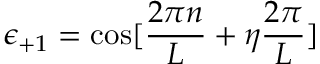<formula> <loc_0><loc_0><loc_500><loc_500>\epsilon _ { + 1 } = \cos [ \frac { 2 \pi n } { L } + \eta \frac { 2 \pi } { L } ]</formula> 